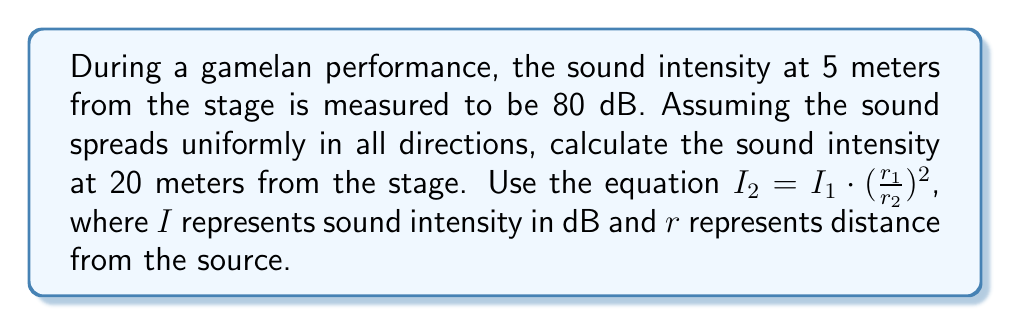Provide a solution to this math problem. To solve this problem, we'll use the inverse square law for sound intensity, given by the equation:

$$I_2 = I_1 \cdot (\frac{r_1}{r_2})^2$$

Where:
$I_1 = 80$ dB (initial sound intensity)
$r_1 = 5$ meters (initial distance)
$r_2 = 20$ meters (new distance)
$I_2 = $ unknown (sound intensity at the new distance)

Let's substitute these values into the equation:

$$I_2 = 80 \cdot (\frac{5}{20})^2$$

Simplify the fraction inside the parentheses:

$$I_2 = 80 \cdot (\frac{1}{4})^2$$

Calculate the squared term:

$$I_2 = 80 \cdot \frac{1}{16}$$

Perform the final multiplication:

$$I_2 = 5$$

Therefore, the sound intensity at 20 meters from the stage is 5 dB.
Answer: 5 dB 